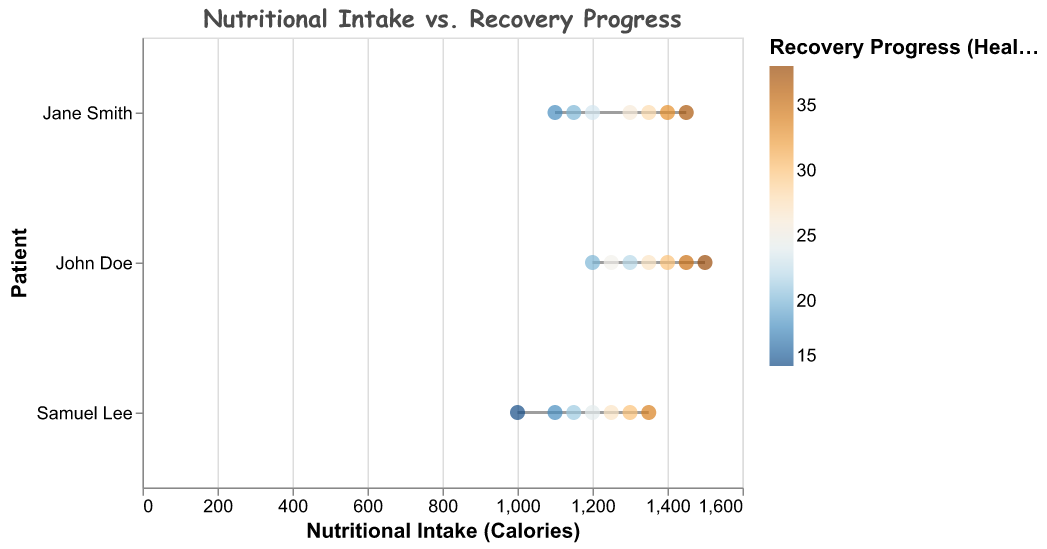What is the title of the figure? The title of the figure is found at the top, formatted in Comic Sans MS font.
Answer: Nutritional Intake vs. Recovery Progress How does John Doe’s nutritional intake change from Day 1 to Day 7? Examine the data points for John Doe from Day 1 to Day 7. His intake starts at 1200 calories on Day 1 and increases to 1500 calories by Day 7.
Answer: It increases What is the highest Recovery Progress (Healing Score) value for Samuel Lee? Look at Samuel Lee's data points and identify the maximum value for the Recovery Progress. The highest value is on Day 7.
Answer: 34 Who had the lowest nutritional intake on Day 1? Compare the nutritional intake for all patients on Day 1. Jane Smith's intake is 1100, and Samuel Lee's is 1000. Samuel Lee has the lowest intake.
Answer: Samuel Lee Who shows the most improvement in Recovery Progress from Day 1 to Day 7? Calculate the improvement by subtracting the Day 1 score from the Day 7 score for each patient. John Doe: 38-20=18, Jane Smith: 37-18=19, Samuel Lee: 34-15=19. Jane Smith and Samuel Lee both improve by 19 points.
Answer: Jane Smith and Samuel Lee Does Jane Smith have higher nutritional intake than John Doe on any day? Compare their nutritional intake values for each day. Jane Smith's intake is never higher than John Doe's on any day.
Answer: No On which day does Samuel Lee's Recovery Progress first reach or exceed 20? Check Samuel Lee's Recovery Progress values day by day. On Day 2, his score reaches 18, and it first exceeds 20 on Day 3 (21).
Answer: Day 3 What is the average Nutritional Intake for John Doe from Day 1 to Day 7? Sum John Doe's daily nutritional intake: 1200 + 1300 + 1250 + 1350 + 1400 + 1450 + 1500 = 9450. There are 7 days, so divide by 7.
Answer: 1350 